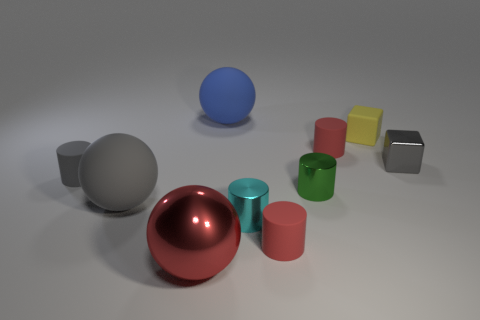Subtract all cyan cylinders. How many cylinders are left? 4 Subtract all small gray cylinders. How many cylinders are left? 4 Subtract all purple cylinders. Subtract all blue blocks. How many cylinders are left? 5 Subtract all blocks. How many objects are left? 8 Subtract 0 yellow balls. How many objects are left? 10 Subtract all big brown balls. Subtract all small green metal cylinders. How many objects are left? 9 Add 8 large red things. How many large red things are left? 9 Add 1 small red rubber cylinders. How many small red rubber cylinders exist? 3 